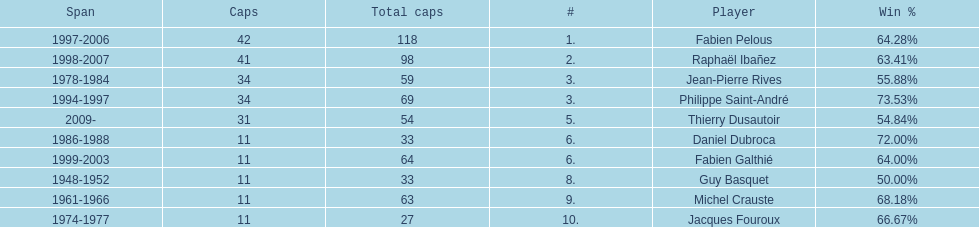Who had the largest win percentage? Philippe Saint-André. 